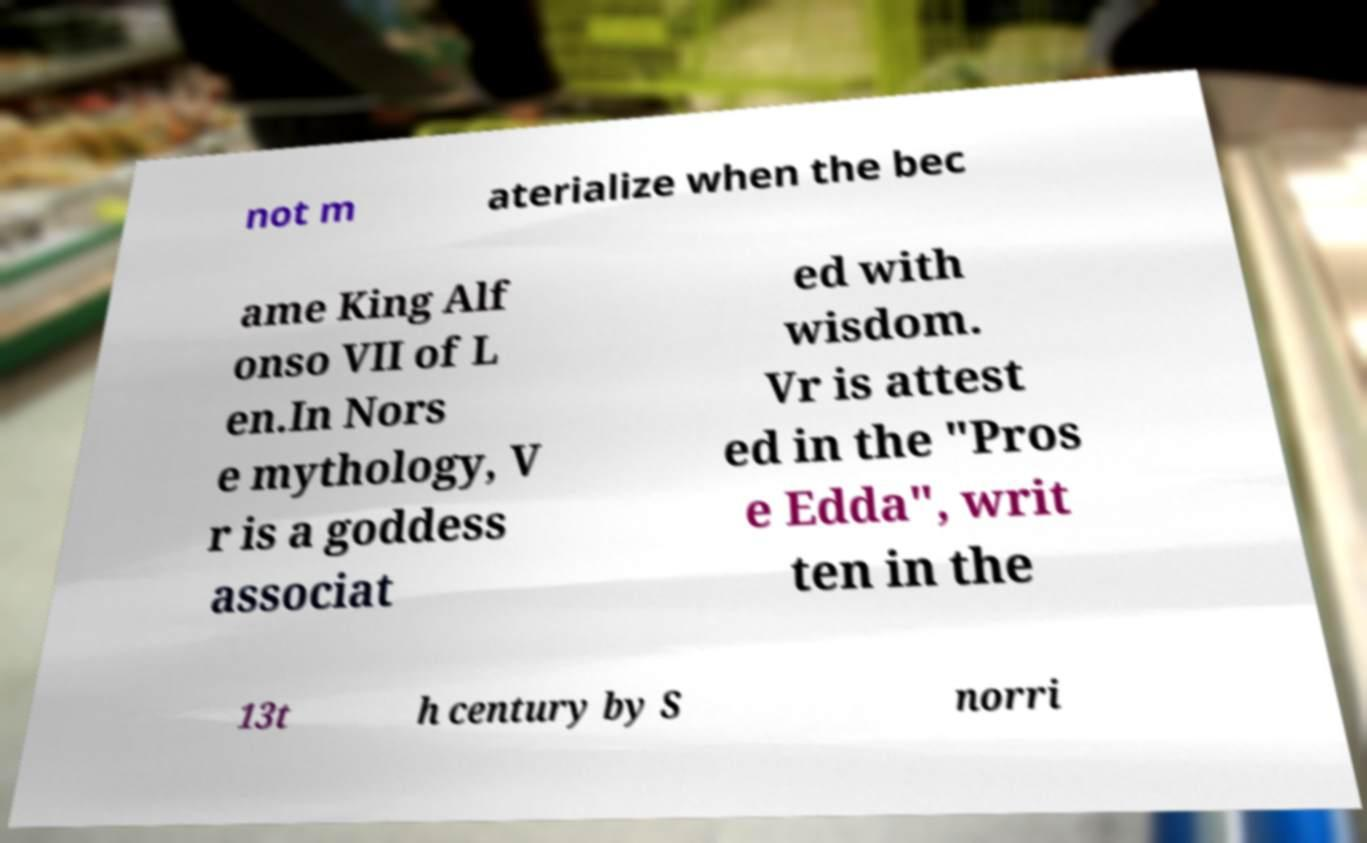Can you read and provide the text displayed in the image?This photo seems to have some interesting text. Can you extract and type it out for me? not m aterialize when the bec ame King Alf onso VII of L en.In Nors e mythology, V r is a goddess associat ed with wisdom. Vr is attest ed in the "Pros e Edda", writ ten in the 13t h century by S norri 